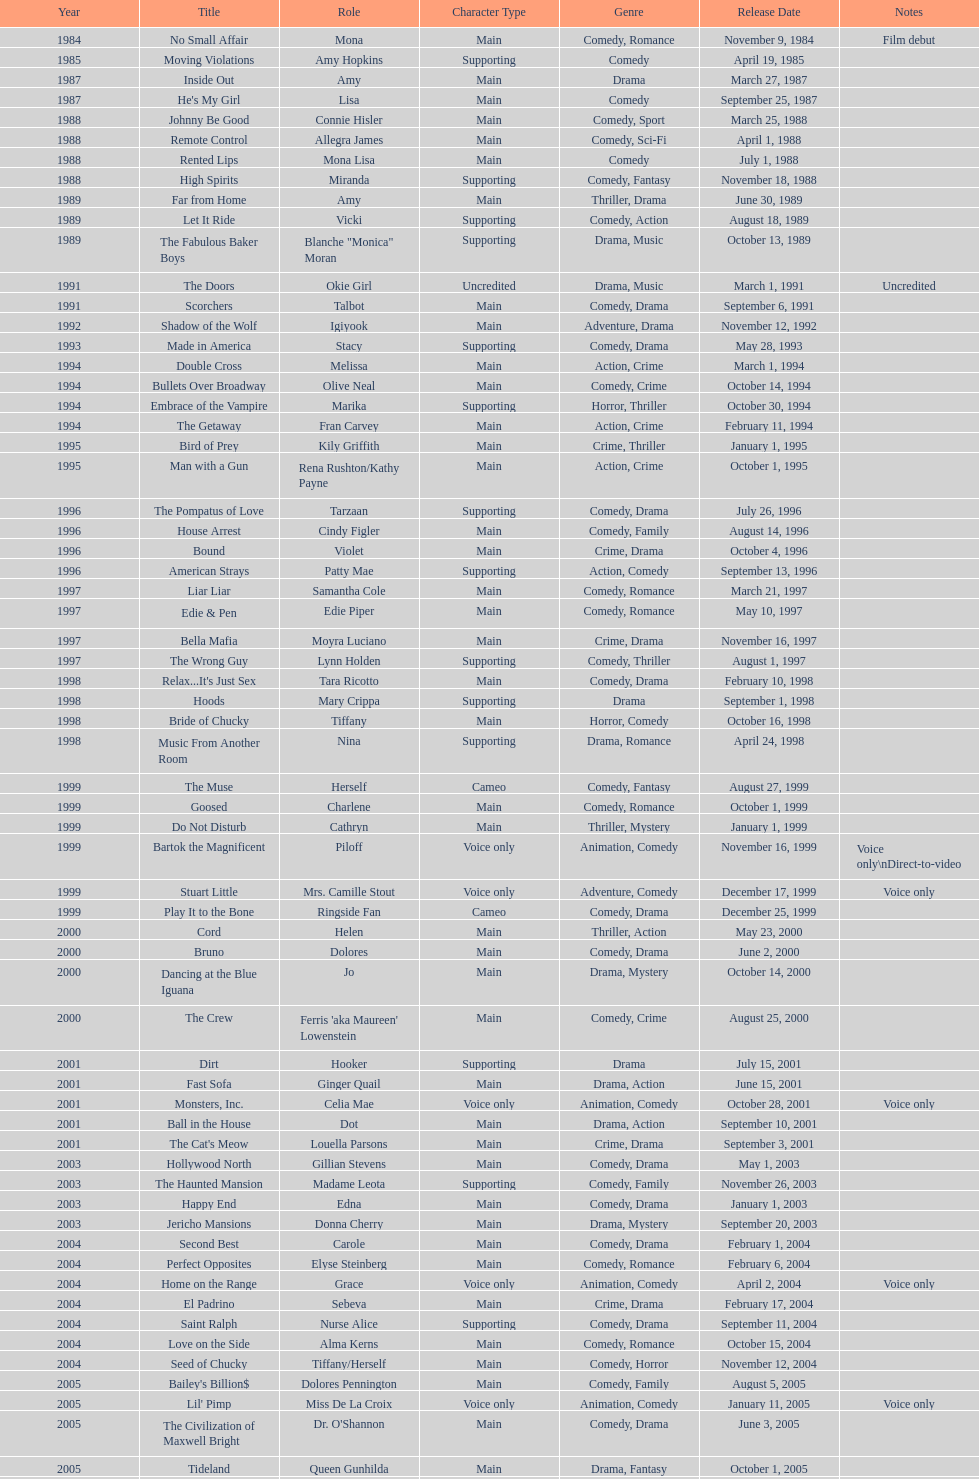How many films does jennifer tilly do a voice over role in? 5. 